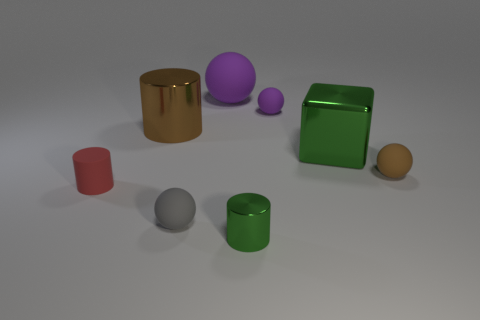How does the arrangement of these objects influence our perception of their sizes? The spatial arrangement of the objects, along with their varying shapes and proximity to each other, can create an illusion known as forced perspective, making some objects appear larger or smaller than they actually are relative to each other. Our perception of size is influenced by context and comparison among the items. 